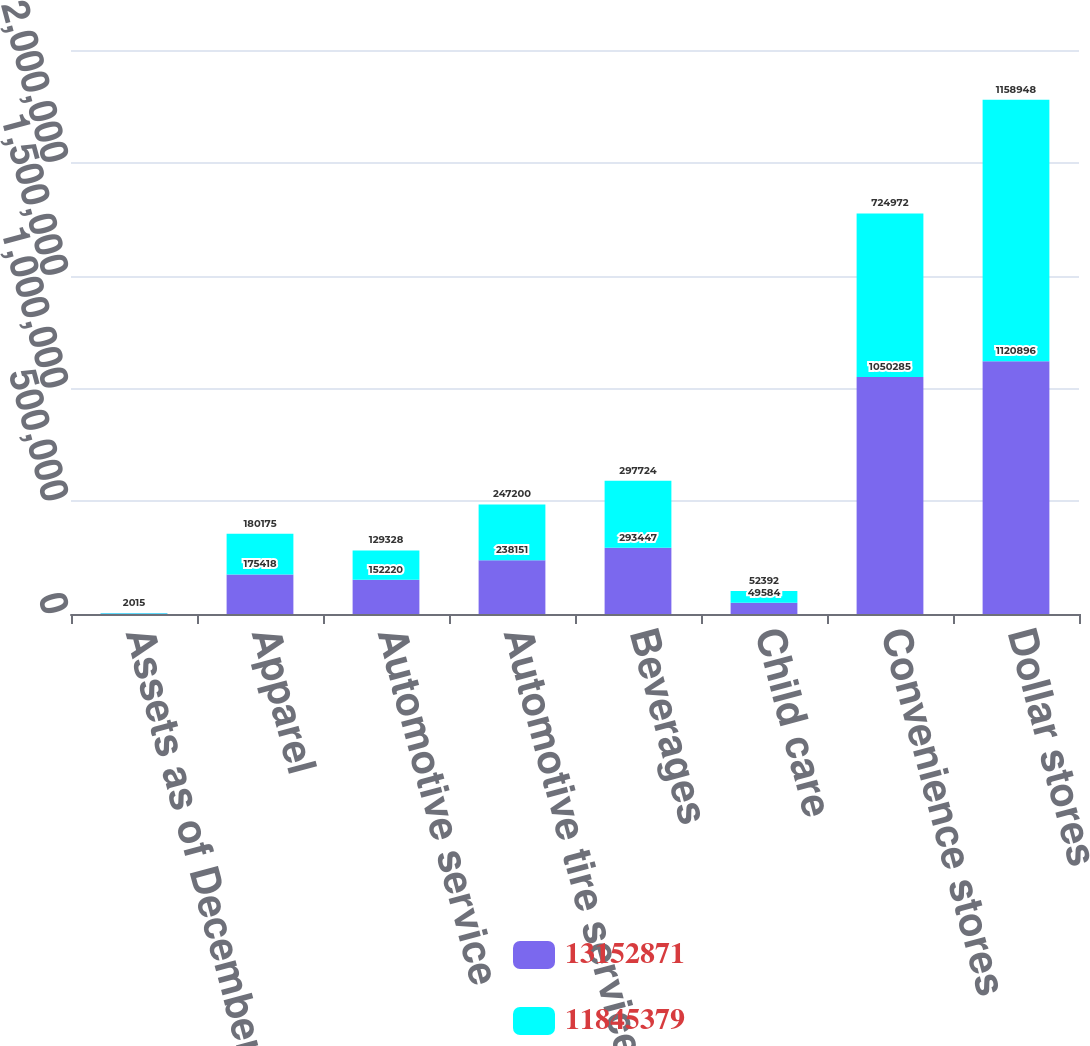<chart> <loc_0><loc_0><loc_500><loc_500><stacked_bar_chart><ecel><fcel>Assets as of December 31<fcel>Apparel<fcel>Automotive service<fcel>Automotive tire services<fcel>Beverages<fcel>Child care<fcel>Convenience stores<fcel>Dollar stores<nl><fcel>1.31529e+07<fcel>2016<fcel>175418<fcel>152220<fcel>238151<fcel>293447<fcel>49584<fcel>1.05028e+06<fcel>1.1209e+06<nl><fcel>1.18454e+07<fcel>2015<fcel>180175<fcel>129328<fcel>247200<fcel>297724<fcel>52392<fcel>724972<fcel>1.15895e+06<nl></chart> 